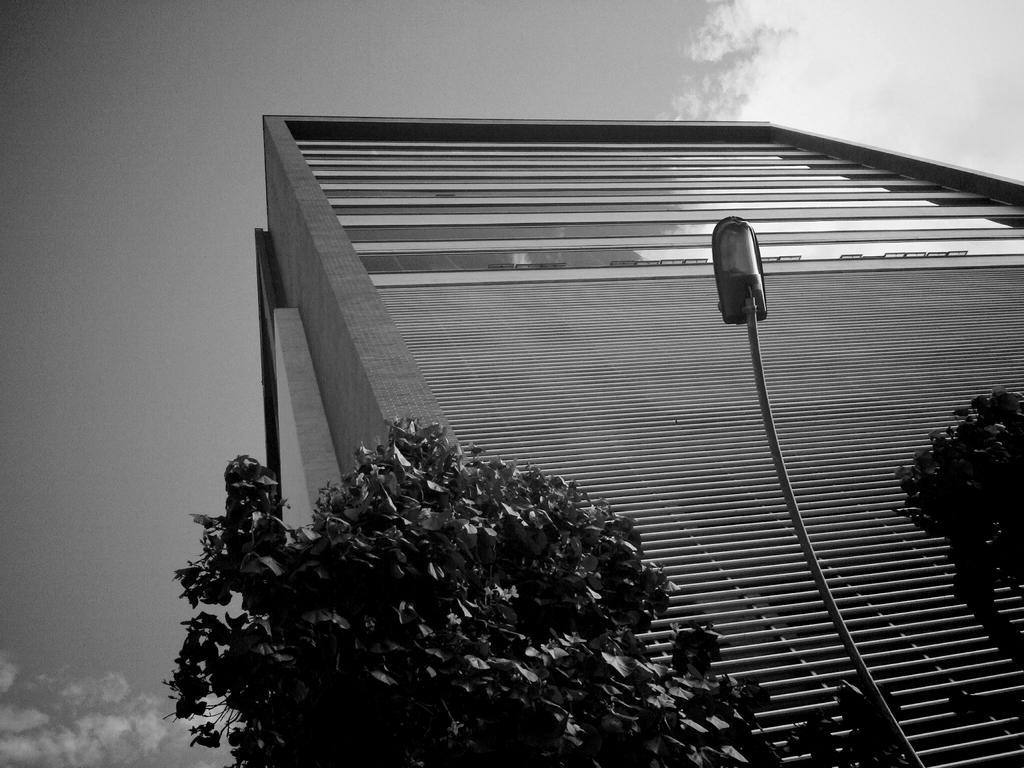In one or two sentences, can you explain what this image depicts? In this picture we can see a building, trees, street light pole and in the background we can see the sky with clouds. 